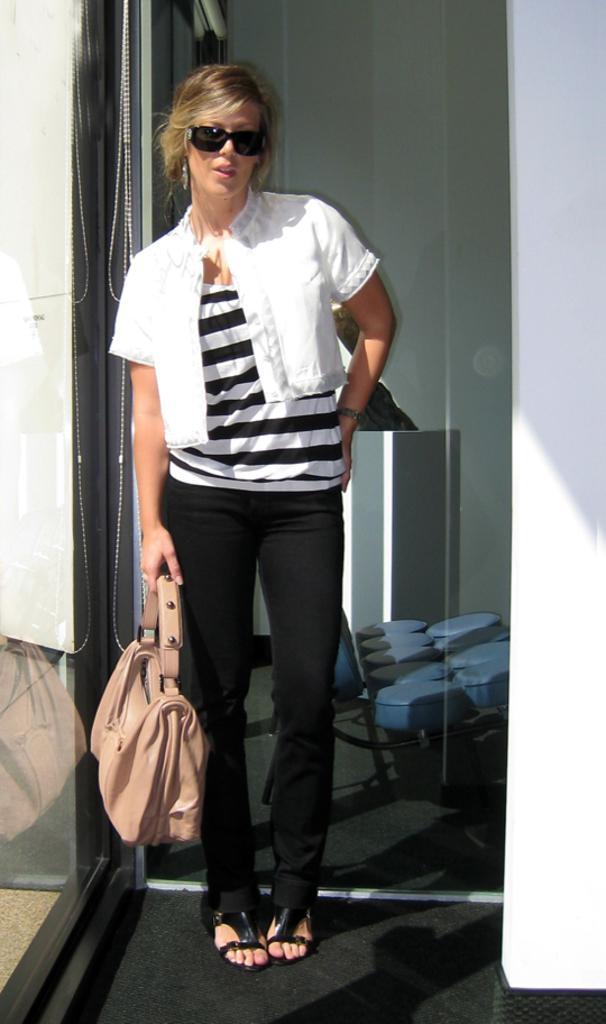How would you summarize this image in a sentence or two? In this image we can see a person standing on the floor and holding a bag. At the back we can see the glasses, through the glasses we can see few objects on the ground. 